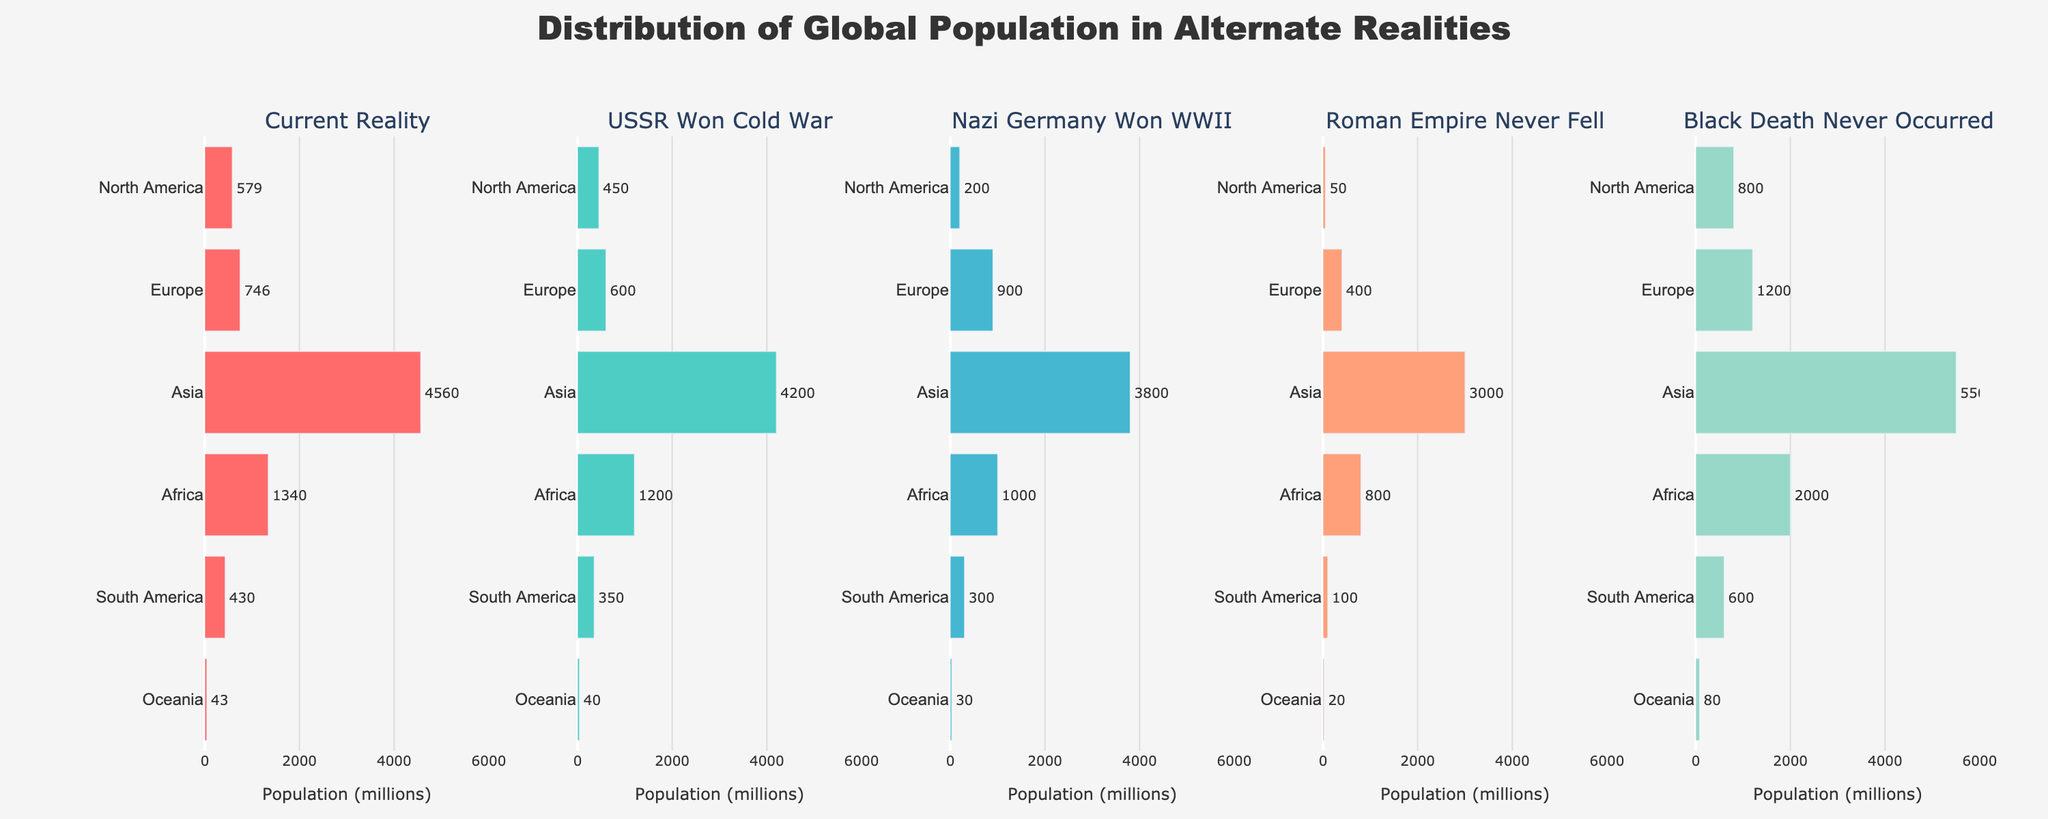what is the title of the figure? The title of the figure is located at the top center.
Answer: Distribution of Global Population in Alternate Realities Which region has the highest population in the current reality? In the current reality, the bar that extends furthest to the right in the "Current Reality" subplot represents the largest population.
Answer: Asia How does the population of Europe change if the Roman Empire never fell compared to the current reality? Compare the bar length for Europe in the "Roman Empire Never Fell" subplot with the "Current Reality" subplot.
Answer: 1200 million vs. 746 million Which historical event leads to the highest population in Africa and what is that population? Look for the largest bar for Africa across all subplots.
Answer: Black Death Never Occurred, 2000 million How much larger is the population of North America in the scenario where the Black Death never occurred compared to when Nazi Germany won WWII? Subtract the North America population in the "Nazi Germany Won WWII" subplot from the population in the "Black Death Never Occurred" subplot.
Answer: 800 - 200 = 600 million By how much does the population of Asia decrease in the scenario where the USSR won the Cold War compared to the current reality? Subtract the population of Asia in the "USSR Won Cold War" subplot from the population in the "Current Reality" subplot.
Answer: 4560 - 4200 = 360 million Which region has the least population when Nazi Germany won WWII? Identify the smallest bar for the "Nazi Germany Won WWII" subplot.
Answer: Oceania Compare the total population of South America across all alternate realities. Which scenario results in the highest population? Sum the population values for South America across all subplots and identify the maximum.
Answer: Black Death Never Occurred How does the population of Oceania in the present reality compare to that in the alternate reality where the USSR won the Cold War? Compare the bar lengths for Oceania between the "Current Reality" and "USSR Won Cold War" subplots.
Answer: 43 million vs. 40 million What is the approximate combined population of Europe and Africa in the current reality? Add the population values for Europe and Africa in the "Current Reality" subplot.
Answer: 746 + 1340 = 2086 million 